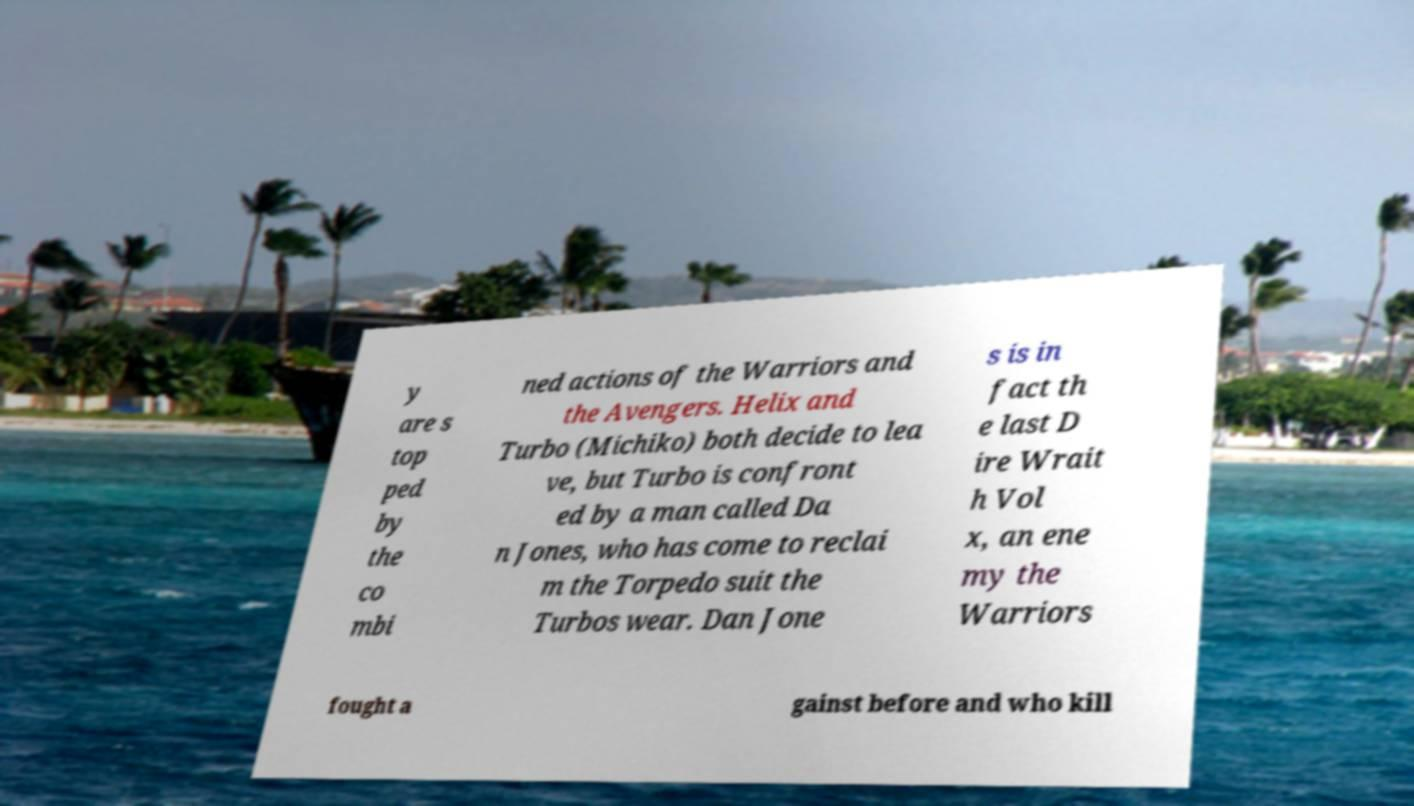There's text embedded in this image that I need extracted. Can you transcribe it verbatim? y are s top ped by the co mbi ned actions of the Warriors and the Avengers. Helix and Turbo (Michiko) both decide to lea ve, but Turbo is confront ed by a man called Da n Jones, who has come to reclai m the Torpedo suit the Turbos wear. Dan Jone s is in fact th e last D ire Wrait h Vol x, an ene my the Warriors fought a gainst before and who kill 